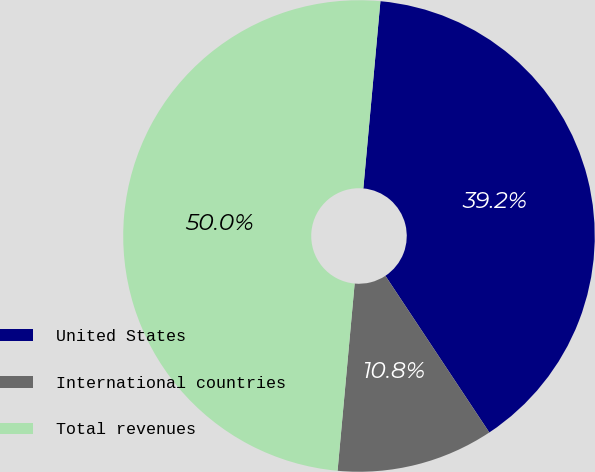Convert chart. <chart><loc_0><loc_0><loc_500><loc_500><pie_chart><fcel>United States<fcel>International countries<fcel>Total revenues<nl><fcel>39.23%<fcel>10.77%<fcel>50.0%<nl></chart> 